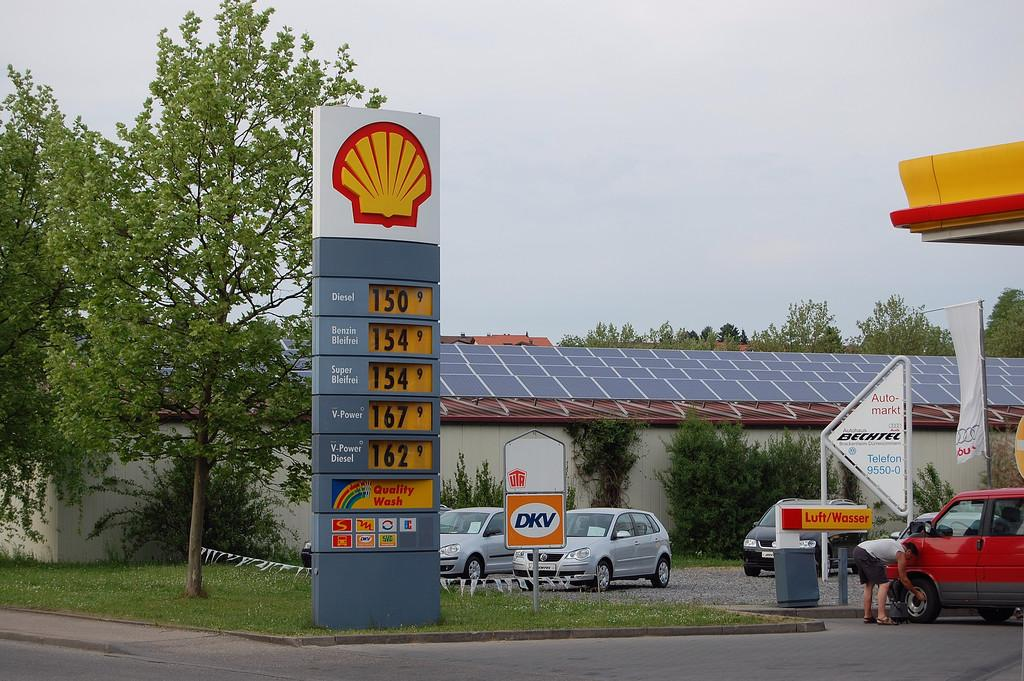What is on the board that is visible in the image? There is a board with information in the image. Who is present in the image? There is a person in the image. What type of vehicles can be seen in the image? There are cars in the image. What is the banner used for in the image? The banner is present in the image, but its purpose is not clear from the facts provided. What are the boards on poles used for in the image? The boards on poles are present in the image, but their purpose is not clear from the facts provided. What type of terrain is visible in the image? There is grass visible in the image. What structures are visible in the background of the image? The background of the image includes a wall and a roof top. What type of vegetation is visible in the background of the image? There are trees in the background of the image. What is visible in the sky in the background of the image? The sky is visible in the background of the image. Can you see a star in the sky in the image? There is no mention of a star in the sky in the image. What is the person using to hammer in the image? There is no hammer or any hammering activity visible in the image. 